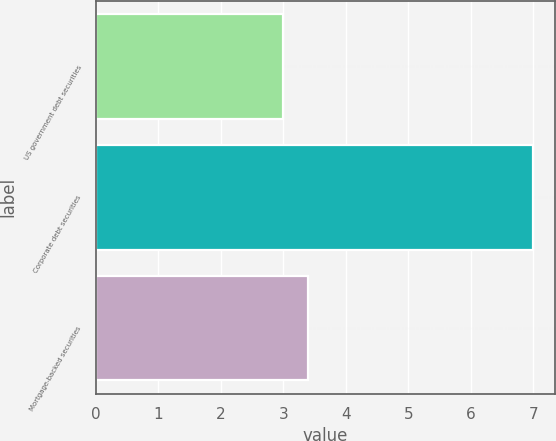Convert chart to OTSL. <chart><loc_0><loc_0><loc_500><loc_500><bar_chart><fcel>US government debt securities<fcel>Corporate debt securities<fcel>Mortgage-backed securities<nl><fcel>3<fcel>7<fcel>3.4<nl></chart> 